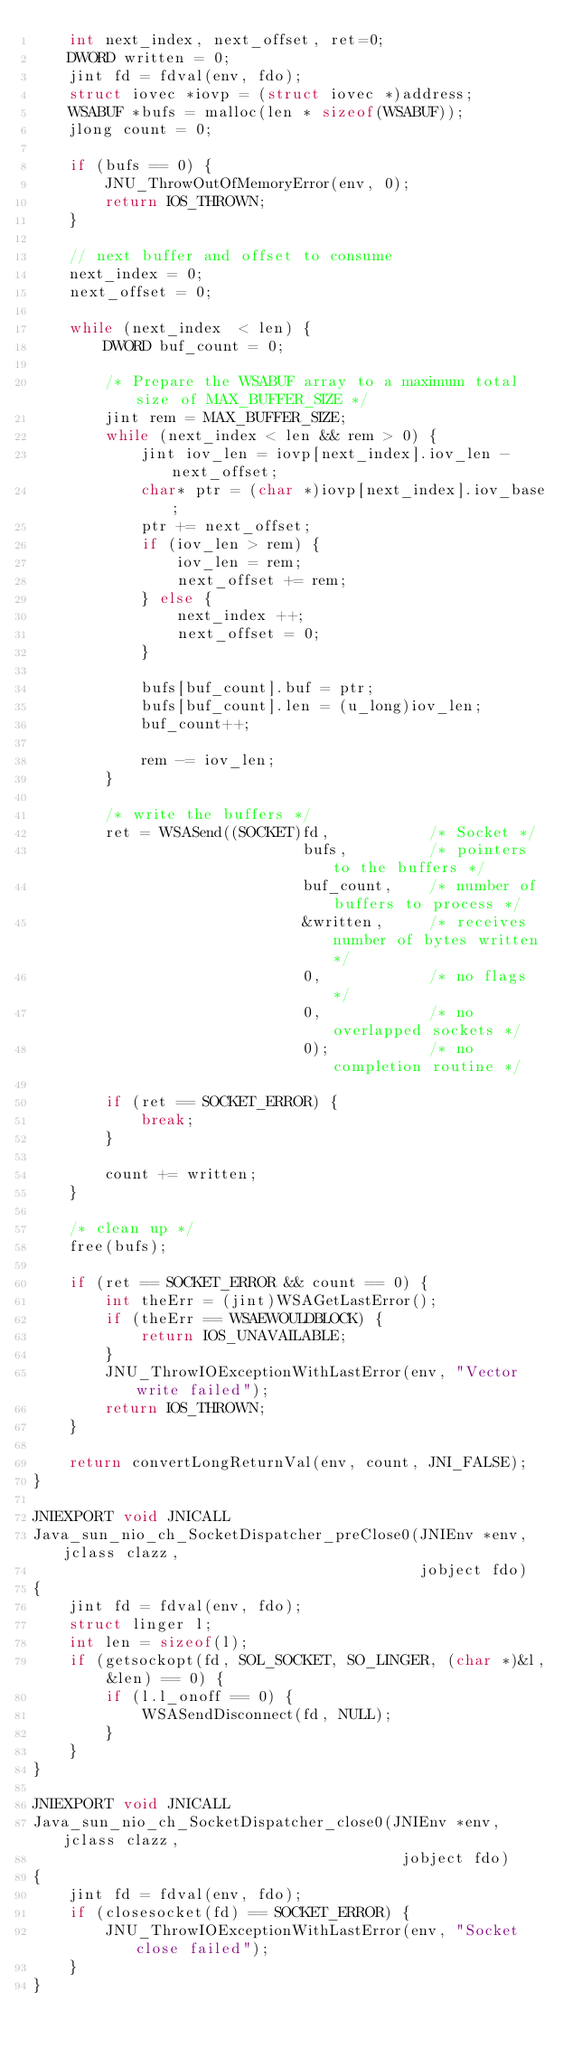Convert code to text. <code><loc_0><loc_0><loc_500><loc_500><_C_>    int next_index, next_offset, ret=0;
    DWORD written = 0;
    jint fd = fdval(env, fdo);
    struct iovec *iovp = (struct iovec *)address;
    WSABUF *bufs = malloc(len * sizeof(WSABUF));
    jlong count = 0;

    if (bufs == 0) {
        JNU_ThrowOutOfMemoryError(env, 0);
        return IOS_THROWN;
    }

    // next buffer and offset to consume
    next_index = 0;
    next_offset = 0;

    while (next_index  < len) {
        DWORD buf_count = 0;

        /* Prepare the WSABUF array to a maximum total size of MAX_BUFFER_SIZE */
        jint rem = MAX_BUFFER_SIZE;
        while (next_index < len && rem > 0) {
            jint iov_len = iovp[next_index].iov_len - next_offset;
            char* ptr = (char *)iovp[next_index].iov_base;
            ptr += next_offset;
            if (iov_len > rem) {
                iov_len = rem;
                next_offset += rem;
            } else {
                next_index ++;
                next_offset = 0;
            }

            bufs[buf_count].buf = ptr;
            bufs[buf_count].len = (u_long)iov_len;
            buf_count++;

            rem -= iov_len;
        }

        /* write the buffers */
        ret = WSASend((SOCKET)fd,           /* Socket */
                              bufs,         /* pointers to the buffers */
                              buf_count,    /* number of buffers to process */
                              &written,     /* receives number of bytes written */
                              0,            /* no flags */
                              0,            /* no overlapped sockets */
                              0);           /* no completion routine */

        if (ret == SOCKET_ERROR) {
            break;
        }

        count += written;
    }

    /* clean up */
    free(bufs);

    if (ret == SOCKET_ERROR && count == 0) {
        int theErr = (jint)WSAGetLastError();
        if (theErr == WSAEWOULDBLOCK) {
            return IOS_UNAVAILABLE;
        }
        JNU_ThrowIOExceptionWithLastError(env, "Vector write failed");
        return IOS_THROWN;
    }

    return convertLongReturnVal(env, count, JNI_FALSE);
}

JNIEXPORT void JNICALL
Java_sun_nio_ch_SocketDispatcher_preClose0(JNIEnv *env, jclass clazz,
                                           jobject fdo)
{
    jint fd = fdval(env, fdo);
    struct linger l;
    int len = sizeof(l);
    if (getsockopt(fd, SOL_SOCKET, SO_LINGER, (char *)&l, &len) == 0) {
        if (l.l_onoff == 0) {
            WSASendDisconnect(fd, NULL);
        }
    }
}

JNIEXPORT void JNICALL
Java_sun_nio_ch_SocketDispatcher_close0(JNIEnv *env, jclass clazz,
                                         jobject fdo)
{
    jint fd = fdval(env, fdo);
    if (closesocket(fd) == SOCKET_ERROR) {
        JNU_ThrowIOExceptionWithLastError(env, "Socket close failed");
    }
}
</code> 